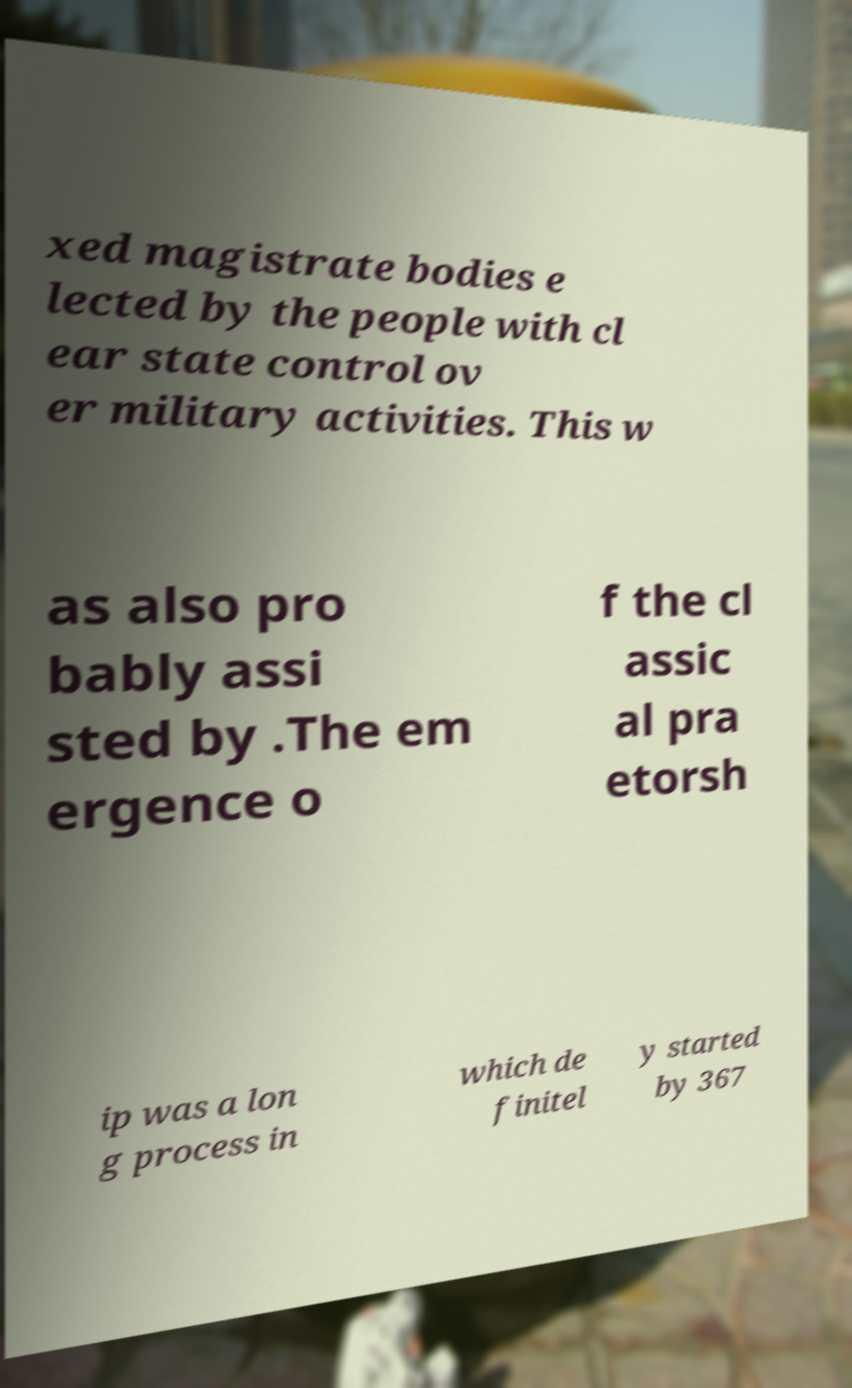Can you accurately transcribe the text from the provided image for me? xed magistrate bodies e lected by the people with cl ear state control ov er military activities. This w as also pro bably assi sted by .The em ergence o f the cl assic al pra etorsh ip was a lon g process in which de finitel y started by 367 